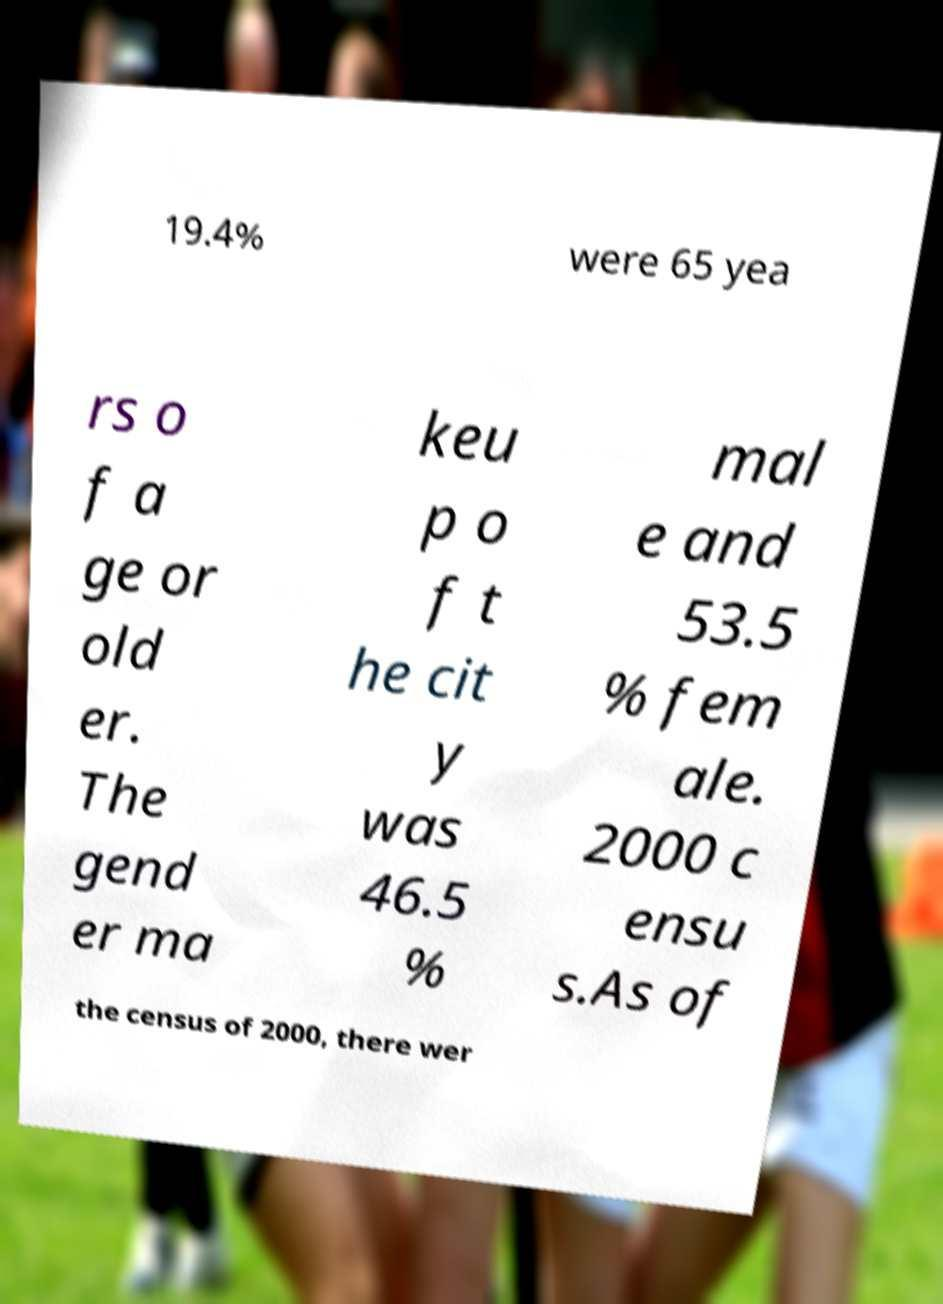Please read and relay the text visible in this image. What does it say? 19.4% were 65 yea rs o f a ge or old er. The gend er ma keu p o f t he cit y was 46.5 % mal e and 53.5 % fem ale. 2000 c ensu s.As of the census of 2000, there wer 